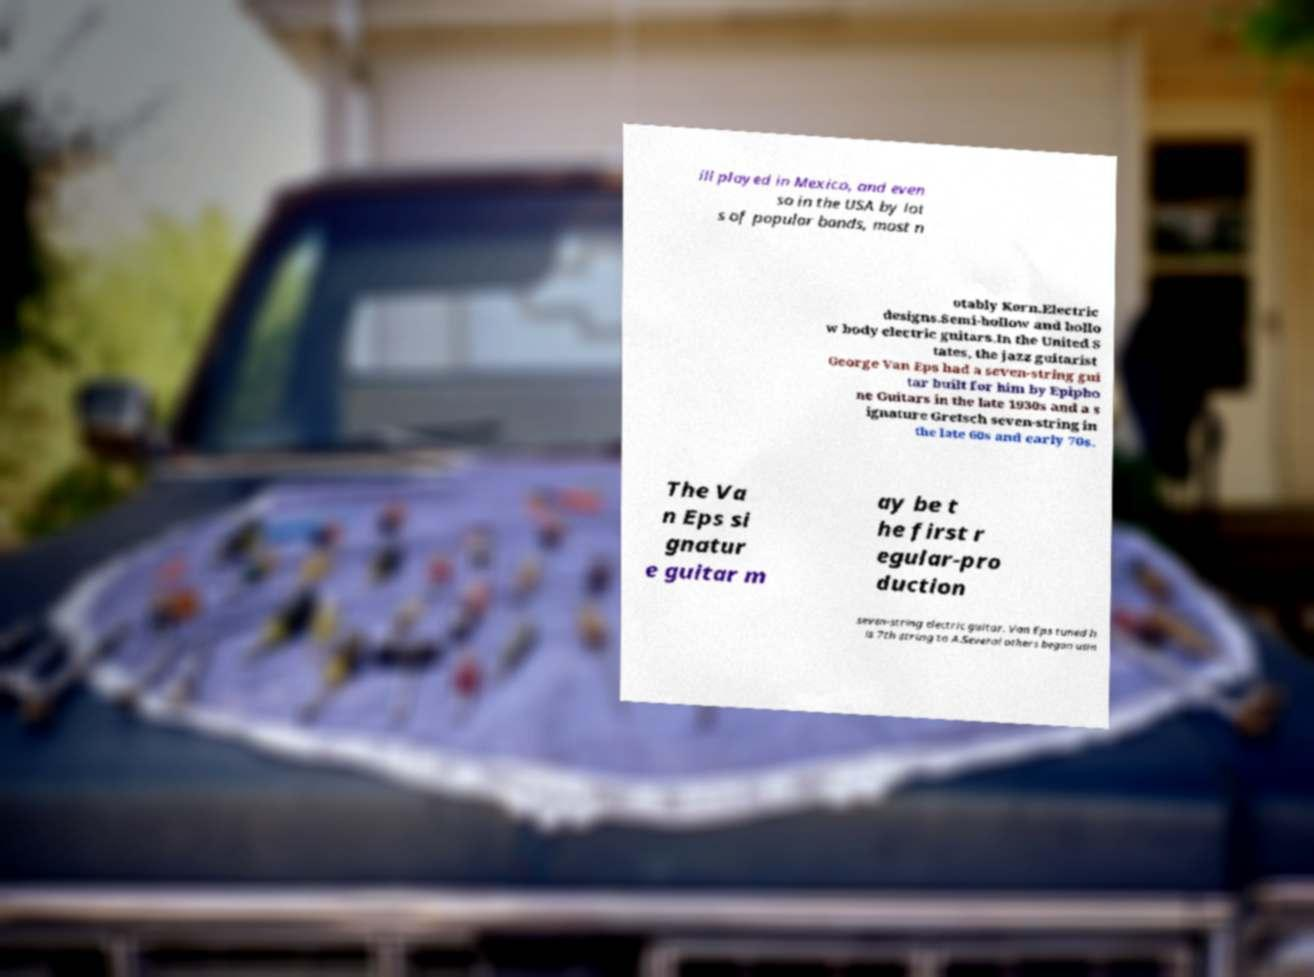Can you read and provide the text displayed in the image?This photo seems to have some interesting text. Can you extract and type it out for me? ill played in Mexico, and even so in the USA by lot s of popular bands, most n otably Korn.Electric designs.Semi-hollow and hollo w body electric guitars.In the United S tates, the jazz guitarist George Van Eps had a seven-string gui tar built for him by Epipho ne Guitars in the late 1930s and a s ignature Gretsch seven-string in the late 60s and early 70s. The Va n Eps si gnatur e guitar m ay be t he first r egular-pro duction seven-string electric guitar. Van Eps tuned h is 7th string to A.Several others began usin 